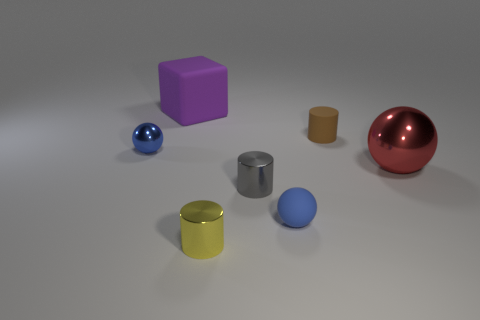Subtract all big balls. How many balls are left? 2 Add 3 blue balls. How many objects exist? 10 Subtract all balls. How many objects are left? 4 Subtract all gray blocks. How many blue spheres are left? 2 Subtract all blue balls. How many balls are left? 1 Subtract 2 cylinders. How many cylinders are left? 1 Subtract 0 brown blocks. How many objects are left? 7 Subtract all green balls. Subtract all brown cylinders. How many balls are left? 3 Subtract all brown objects. Subtract all cubes. How many objects are left? 5 Add 4 metallic balls. How many metallic balls are left? 6 